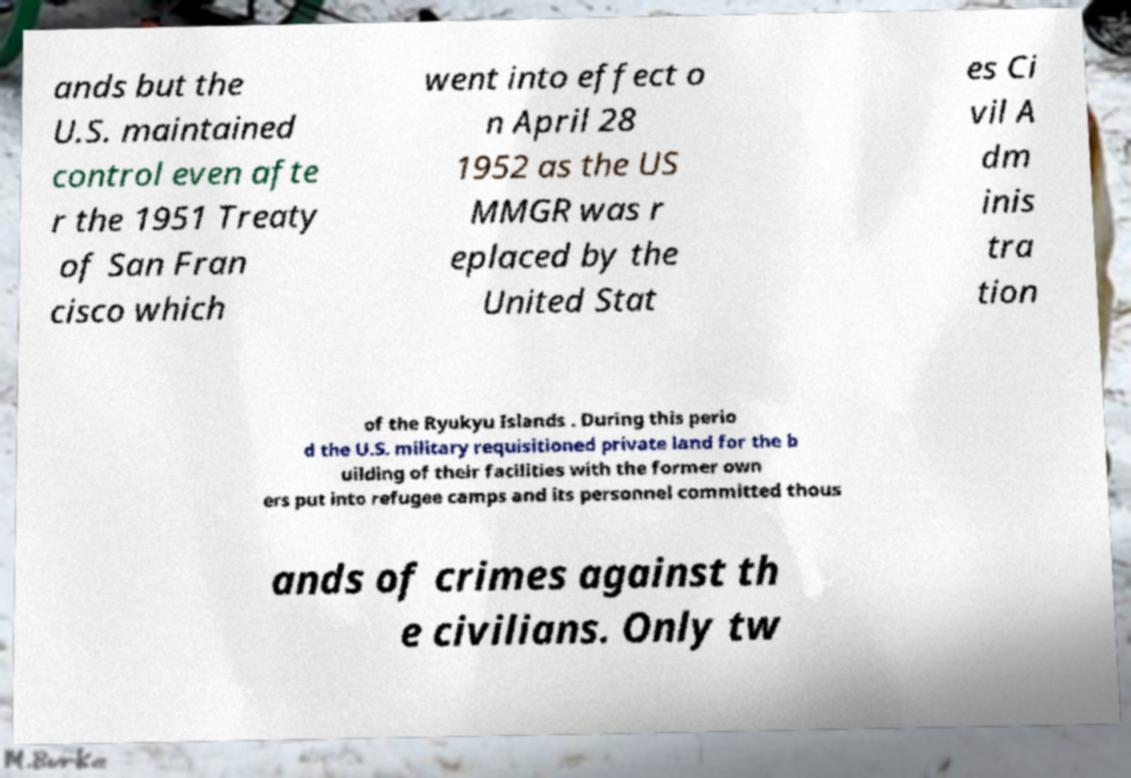I need the written content from this picture converted into text. Can you do that? ands but the U.S. maintained control even afte r the 1951 Treaty of San Fran cisco which went into effect o n April 28 1952 as the US MMGR was r eplaced by the United Stat es Ci vil A dm inis tra tion of the Ryukyu Islands . During this perio d the U.S. military requisitioned private land for the b uilding of their facilities with the former own ers put into refugee camps and its personnel committed thous ands of crimes against th e civilians. Only tw 